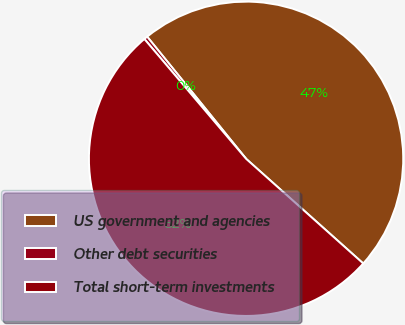Convert chart to OTSL. <chart><loc_0><loc_0><loc_500><loc_500><pie_chart><fcel>US government and agencies<fcel>Other debt securities<fcel>Total short-term investments<nl><fcel>47.44%<fcel>0.37%<fcel>52.19%<nl></chart> 